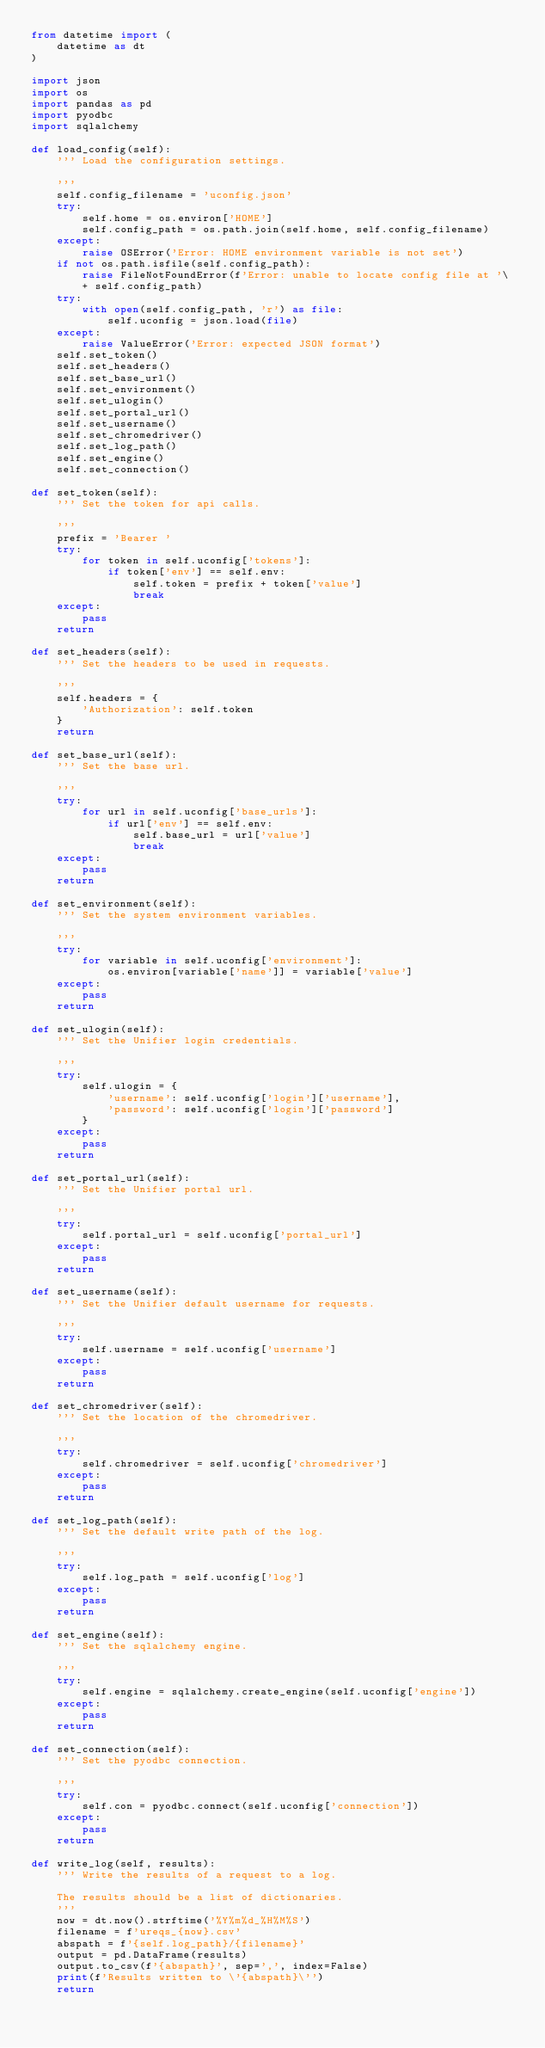<code> <loc_0><loc_0><loc_500><loc_500><_Python_>from datetime import (
    datetime as dt
)

import json
import os
import pandas as pd
import pyodbc
import sqlalchemy

def load_config(self):
    ''' Load the configuration settings.

    '''
    self.config_filename = 'uconfig.json'
    try:
        self.home = os.environ['HOME']
        self.config_path = os.path.join(self.home, self.config_filename)
    except:
        raise OSError('Error: HOME environment variable is not set')
    if not os.path.isfile(self.config_path):
        raise FileNotFoundError(f'Error: unable to locate config file at '\
        + self.config_path)
    try:
        with open(self.config_path, 'r') as file:
            self.uconfig = json.load(file)
    except:
        raise ValueError('Error: expected JSON format')
    self.set_token()
    self.set_headers()
    self.set_base_url()
    self.set_environment()
    self.set_ulogin()
    self.set_portal_url()
    self.set_username()
    self.set_chromedriver()
    self.set_log_path()
    self.set_engine()
    self.set_connection()

def set_token(self):
    ''' Set the token for api calls.

    '''
    prefix = 'Bearer '
    try:
        for token in self.uconfig['tokens']:
            if token['env'] == self.env:
                self.token = prefix + token['value']
                break
    except:
        pass
    return

def set_headers(self):
    ''' Set the headers to be used in requests.

    '''
    self.headers = {
        'Authorization': self.token
    }
    return

def set_base_url(self):
    ''' Set the base url.

    '''
    try:
        for url in self.uconfig['base_urls']:
            if url['env'] == self.env:
                self.base_url = url['value']
                break
    except:
        pass
    return

def set_environment(self):
    ''' Set the system environment variables.

    '''
    try:
        for variable in self.uconfig['environment']:
            os.environ[variable['name']] = variable['value']
    except:
        pass
    return

def set_ulogin(self):
    ''' Set the Unifier login credentials.

    '''
    try:
        self.ulogin = {
            'username': self.uconfig['login']['username'],
            'password': self.uconfig['login']['password']
        }
    except:
        pass
    return

def set_portal_url(self):
    ''' Set the Unifier portal url.

    '''
    try:
        self.portal_url = self.uconfig['portal_url']
    except:
        pass
    return

def set_username(self):
    ''' Set the Unifier default username for requests.

    '''
    try:
        self.username = self.uconfig['username']
    except:
        pass
    return

def set_chromedriver(self):
    ''' Set the location of the chromedriver.

    '''
    try:
        self.chromedriver = self.uconfig['chromedriver']
    except:
        pass
    return

def set_log_path(self):
    ''' Set the default write path of the log.

    '''
    try:
        self.log_path = self.uconfig['log']
    except:
        pass
    return

def set_engine(self):
    ''' Set the sqlalchemy engine.

    '''
    try:
        self.engine = sqlalchemy.create_engine(self.uconfig['engine'])
    except:
        pass
    return

def set_connection(self):
    ''' Set the pyodbc connection.

    '''
    try:
        self.con = pyodbc.connect(self.uconfig['connection'])
    except:
        pass
    return

def write_log(self, results):
    ''' Write the results of a request to a log.

    The results should be a list of dictionaries.
    '''
    now = dt.now().strftime('%Y%m%d_%H%M%S')
    filename = f'ureqs_{now}.csv'
    abspath = f'{self.log_path}/{filename}'
    output = pd.DataFrame(results)
    output.to_csv(f'{abspath}', sep=',', index=False)
    print(f'Results written to \'{abspath}\'')
    return
</code> 